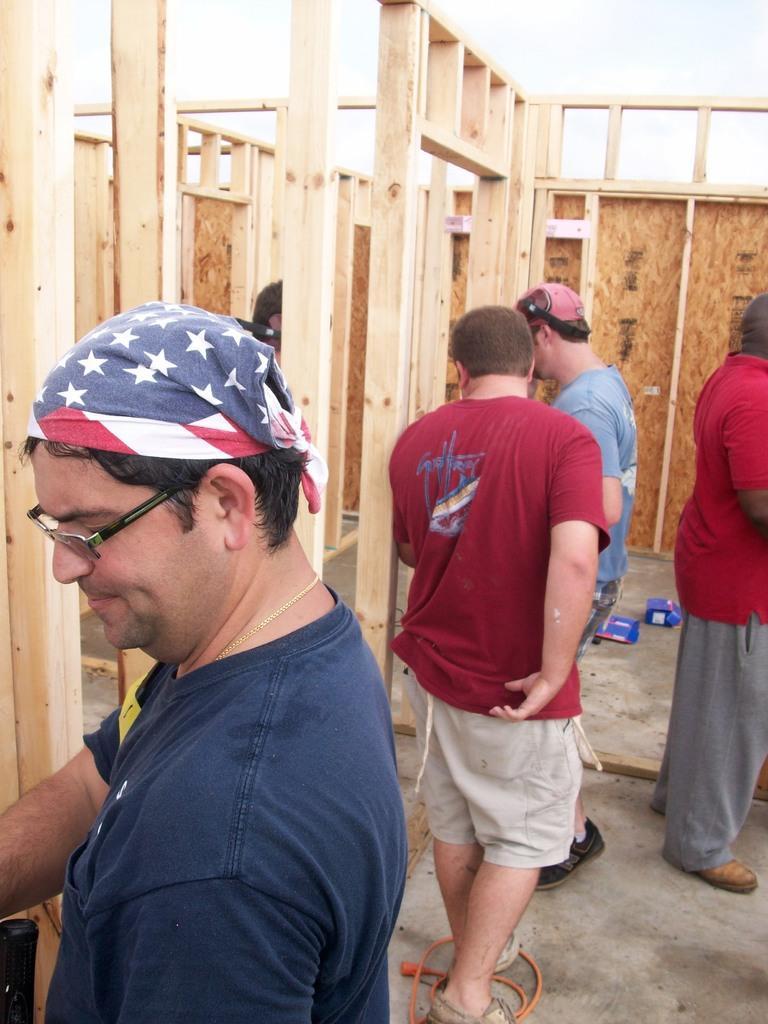Describe this image in one or two sentences. In this image there are a few men standing on the floor. There are boxes and a wire on the floor. Behind them there are wooden walls. 